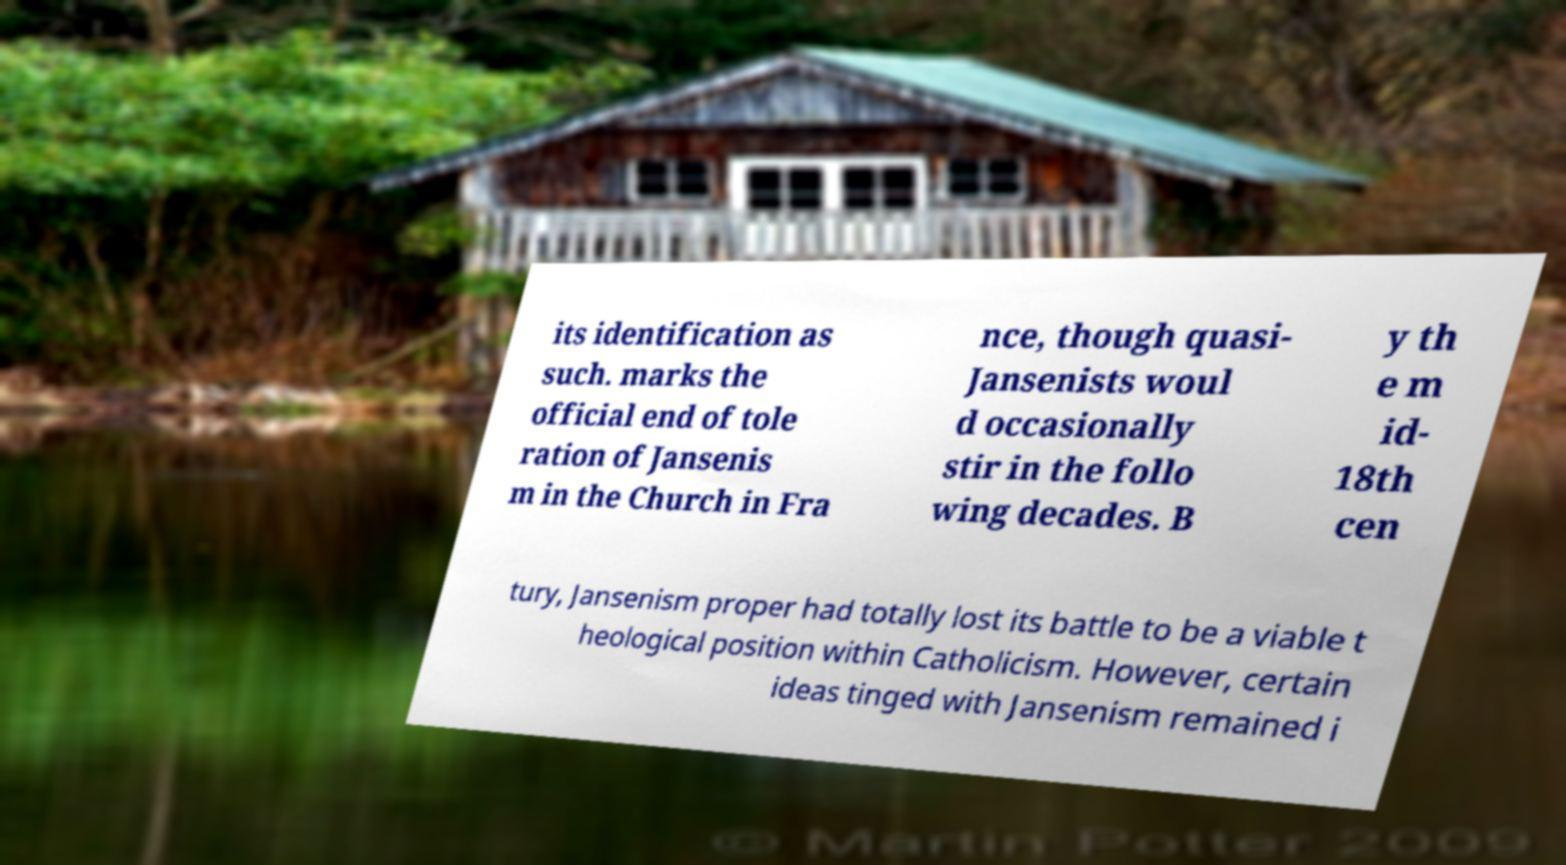Please read and relay the text visible in this image. What does it say? its identification as such. marks the official end of tole ration of Jansenis m in the Church in Fra nce, though quasi- Jansenists woul d occasionally stir in the follo wing decades. B y th e m id- 18th cen tury, Jansenism proper had totally lost its battle to be a viable t heological position within Catholicism. However, certain ideas tinged with Jansenism remained i 